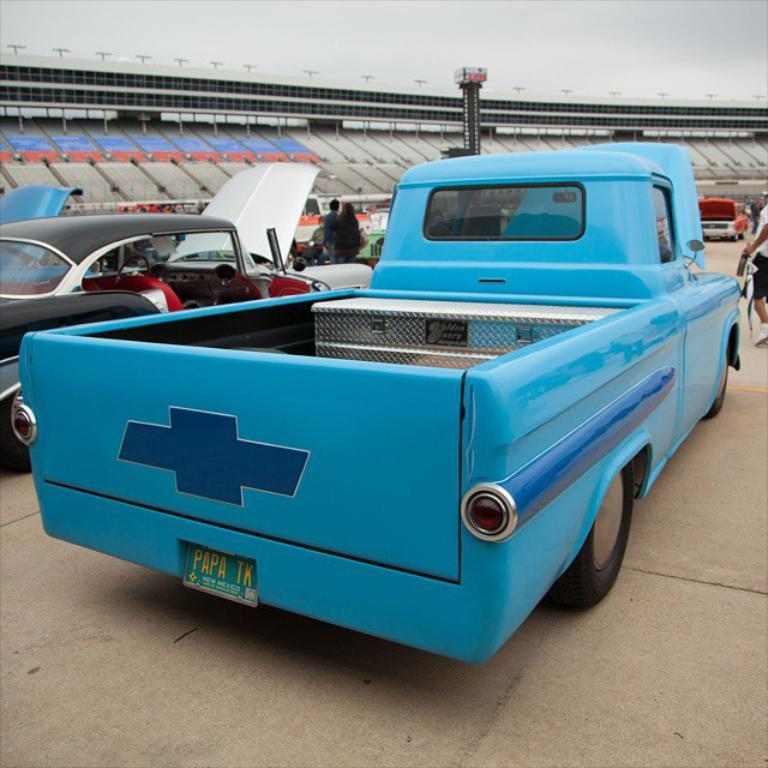What types of objects are present in the image? There are vehicles and people in the image. Can you describe the setting or location in the image? There is a stadium in the background of the image. What is visible at the top of the image? The sky is visible at the top of the image. What type of boat can be seen in the image? There is no boat present in the image. What sound can be heard coming from the stadium in the image? The image is a still picture, so no sound can be heard. 